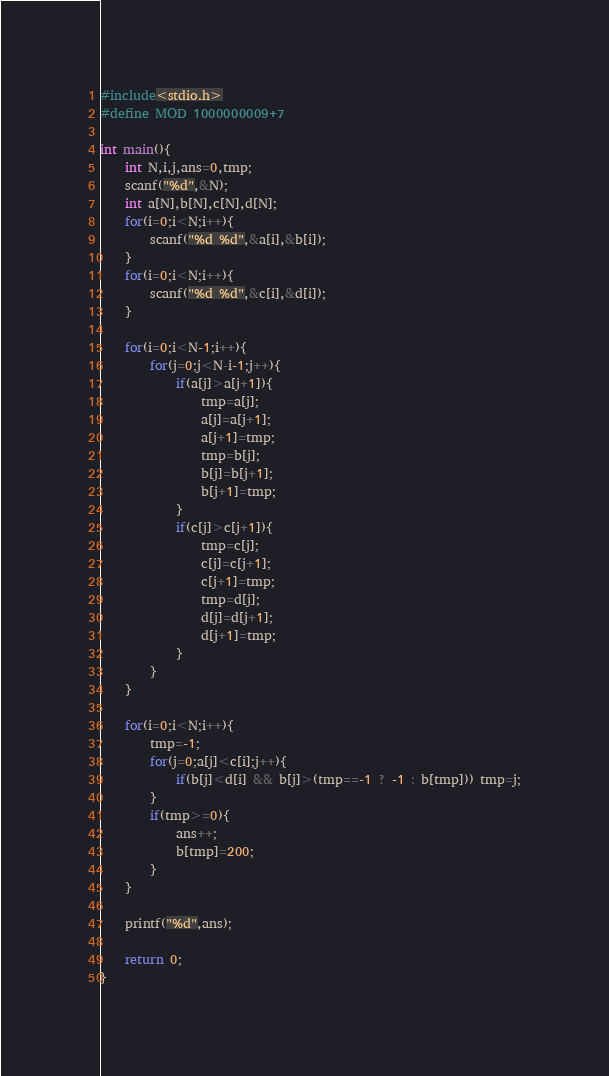<code> <loc_0><loc_0><loc_500><loc_500><_C_>#include<stdio.h>
#define MOD 1000000009+7

int main(){
	int N,i,j,ans=0,tmp;
	scanf("%d",&N);
	int a[N],b[N],c[N],d[N];
	for(i=0;i<N;i++){
		scanf("%d %d",&a[i],&b[i]);
	}
	for(i=0;i<N;i++){
		scanf("%d %d",&c[i],&d[i]);
	}
	
	for(i=0;i<N-1;i++){
		for(j=0;j<N-i-1;j++){
			if(a[j]>a[j+1]){
				tmp=a[j];
				a[j]=a[j+1];
				a[j+1]=tmp;
				tmp=b[j];
				b[j]=b[j+1];
				b[j+1]=tmp;
			}
			if(c[j]>c[j+1]){
				tmp=c[j];
				c[j]=c[j+1];
				c[j+1]=tmp;
				tmp=d[j];
				d[j]=d[j+1];
				d[j+1]=tmp;
			}
		}
	}
	
	for(i=0;i<N;i++){
		tmp=-1;
		for(j=0;a[j]<c[i];j++){
			if(b[j]<d[i] && b[j]>(tmp==-1 ? -1 : b[tmp])) tmp=j;
		}
		if(tmp>=0){
			ans++;
			b[tmp]=200;
		}
	}
	
	printf("%d",ans);
	
	return 0;
}</code> 